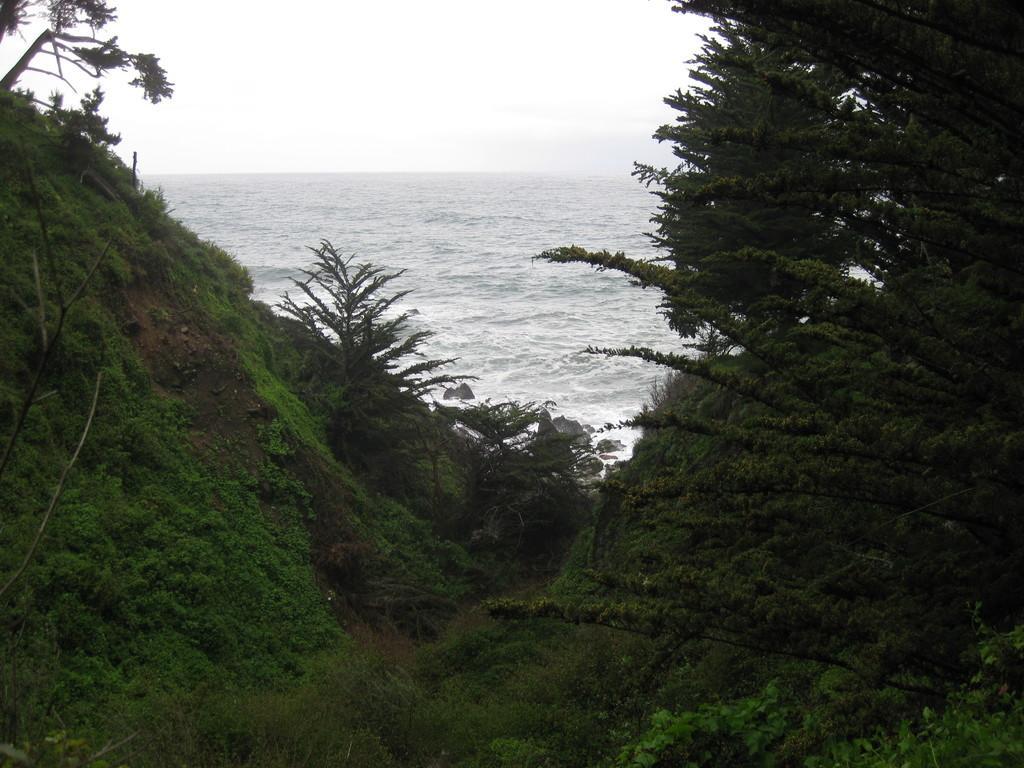In one or two sentences, can you explain what this image depicts? At the bottom of the picture, we see the grass. On either side of the picture, we see trees. In the background, we see water and this water might be in the sea. At the top, we see the sky. 